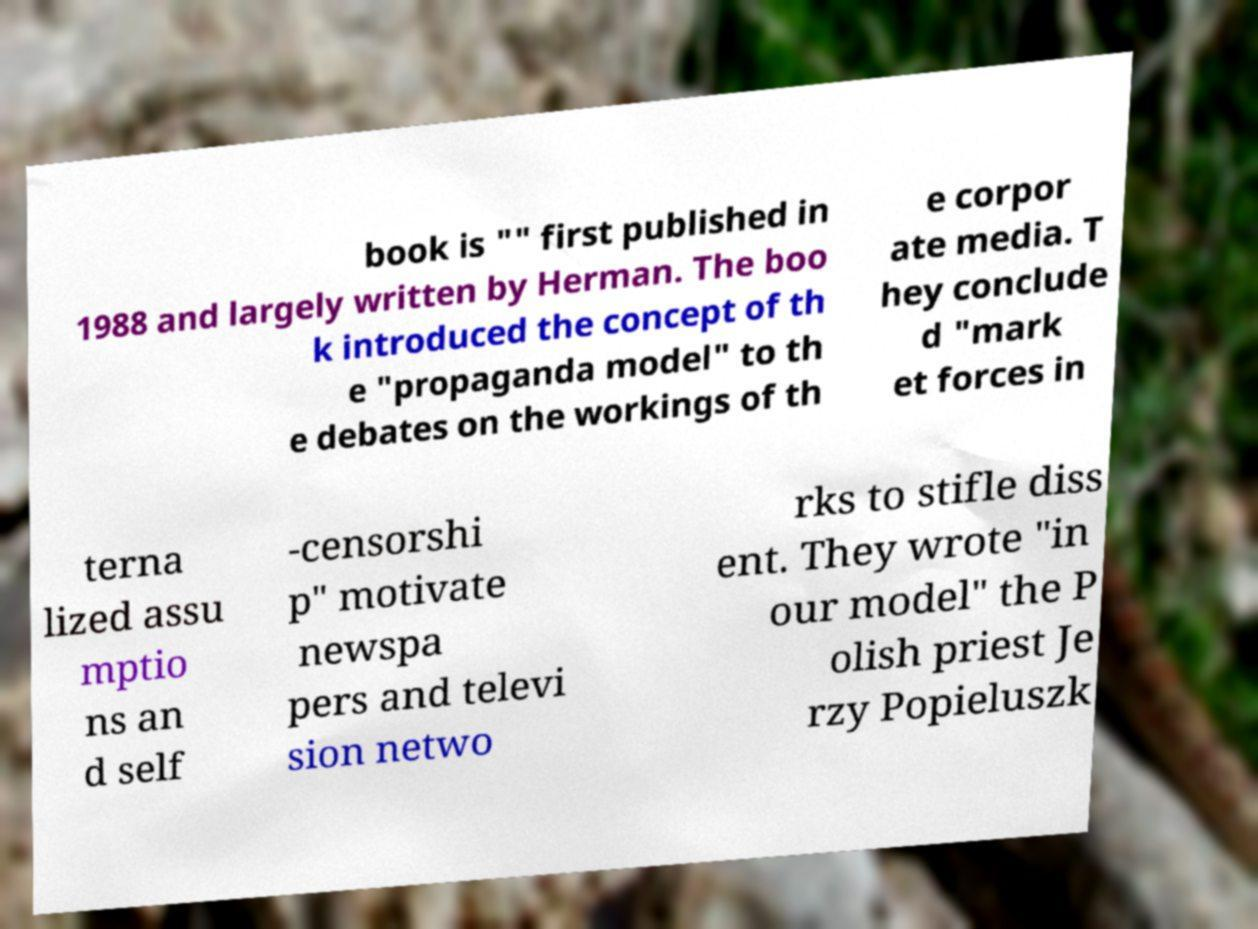Can you read and provide the text displayed in the image?This photo seems to have some interesting text. Can you extract and type it out for me? book is "" first published in 1988 and largely written by Herman. The boo k introduced the concept of th e "propaganda model" to th e debates on the workings of th e corpor ate media. T hey conclude d "mark et forces in terna lized assu mptio ns an d self -censorshi p" motivate newspa pers and televi sion netwo rks to stifle diss ent. They wrote "in our model" the P olish priest Je rzy Popieluszk 